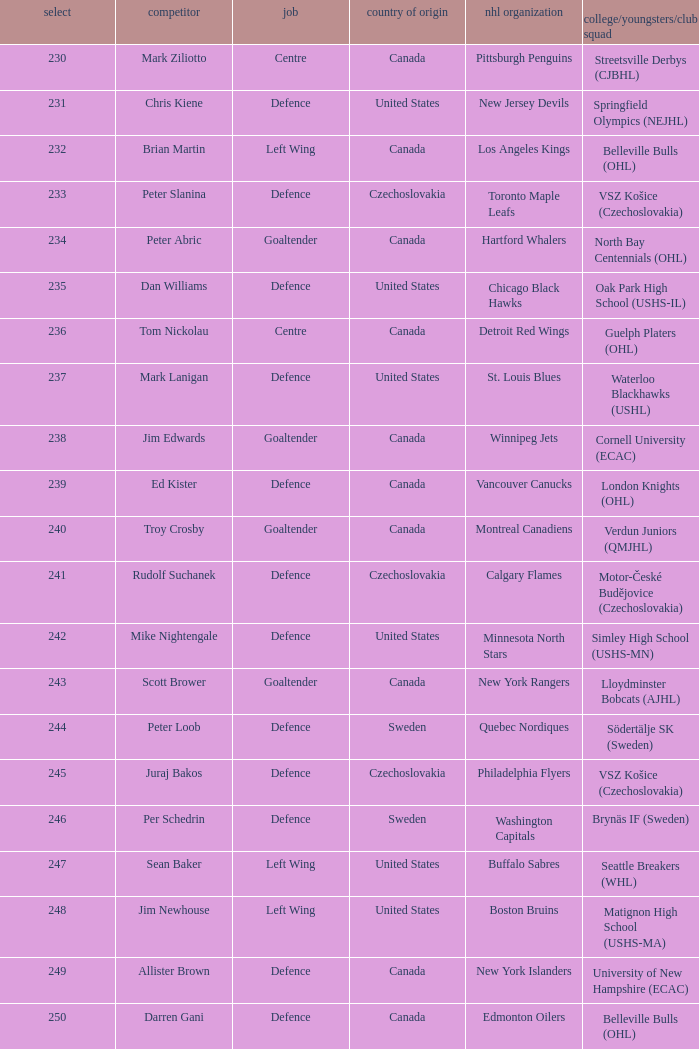What selection was the springfield olympics (nejhl)? 231.0. 